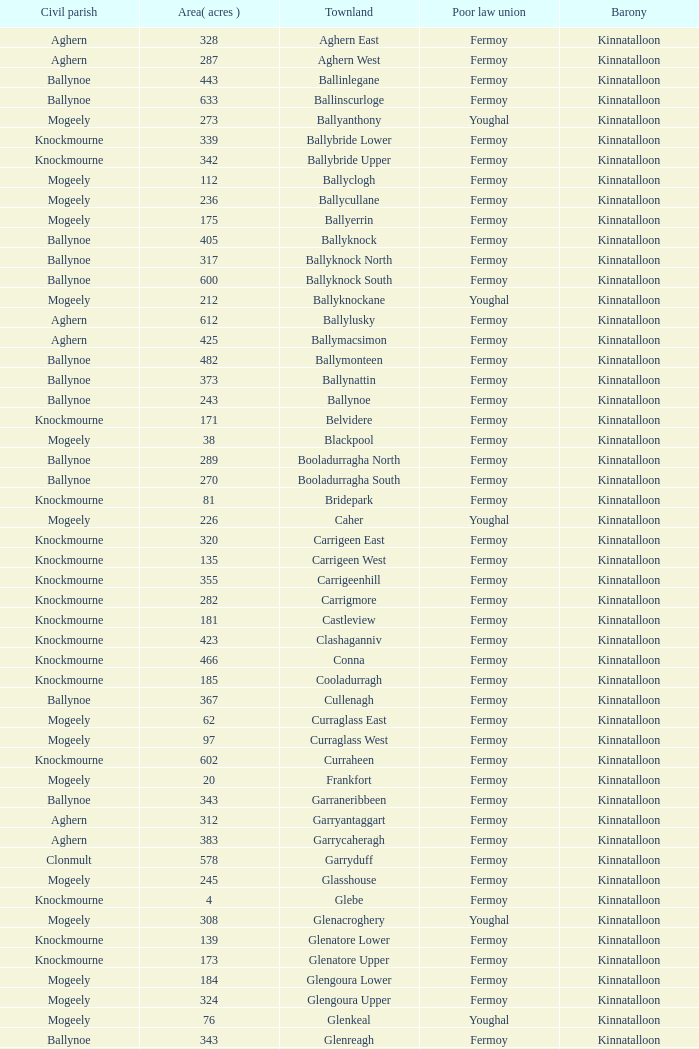Name the civil parish for garryduff Clonmult. Could you parse the entire table as a dict? {'header': ['Civil parish', 'Area( acres )', 'Townland', 'Poor law union', 'Barony'], 'rows': [['Aghern', '328', 'Aghern East', 'Fermoy', 'Kinnatalloon'], ['Aghern', '287', 'Aghern West', 'Fermoy', 'Kinnatalloon'], ['Ballynoe', '443', 'Ballinlegane', 'Fermoy', 'Kinnatalloon'], ['Ballynoe', '633', 'Ballinscurloge', 'Fermoy', 'Kinnatalloon'], ['Mogeely', '273', 'Ballyanthony', 'Youghal', 'Kinnatalloon'], ['Knockmourne', '339', 'Ballybride Lower', 'Fermoy', 'Kinnatalloon'], ['Knockmourne', '342', 'Ballybride Upper', 'Fermoy', 'Kinnatalloon'], ['Mogeely', '112', 'Ballyclogh', 'Fermoy', 'Kinnatalloon'], ['Mogeely', '236', 'Ballycullane', 'Fermoy', 'Kinnatalloon'], ['Mogeely', '175', 'Ballyerrin', 'Fermoy', 'Kinnatalloon'], ['Ballynoe', '405', 'Ballyknock', 'Fermoy', 'Kinnatalloon'], ['Ballynoe', '317', 'Ballyknock North', 'Fermoy', 'Kinnatalloon'], ['Ballynoe', '600', 'Ballyknock South', 'Fermoy', 'Kinnatalloon'], ['Mogeely', '212', 'Ballyknockane', 'Youghal', 'Kinnatalloon'], ['Aghern', '612', 'Ballylusky', 'Fermoy', 'Kinnatalloon'], ['Aghern', '425', 'Ballymacsimon', 'Fermoy', 'Kinnatalloon'], ['Ballynoe', '482', 'Ballymonteen', 'Fermoy', 'Kinnatalloon'], ['Ballynoe', '373', 'Ballynattin', 'Fermoy', 'Kinnatalloon'], ['Ballynoe', '243', 'Ballynoe', 'Fermoy', 'Kinnatalloon'], ['Knockmourne', '171', 'Belvidere', 'Fermoy', 'Kinnatalloon'], ['Mogeely', '38', 'Blackpool', 'Fermoy', 'Kinnatalloon'], ['Ballynoe', '289', 'Booladurragha North', 'Fermoy', 'Kinnatalloon'], ['Ballynoe', '270', 'Booladurragha South', 'Fermoy', 'Kinnatalloon'], ['Knockmourne', '81', 'Bridepark', 'Fermoy', 'Kinnatalloon'], ['Mogeely', '226', 'Caher', 'Youghal', 'Kinnatalloon'], ['Knockmourne', '320', 'Carrigeen East', 'Fermoy', 'Kinnatalloon'], ['Knockmourne', '135', 'Carrigeen West', 'Fermoy', 'Kinnatalloon'], ['Knockmourne', '355', 'Carrigeenhill', 'Fermoy', 'Kinnatalloon'], ['Knockmourne', '282', 'Carrigmore', 'Fermoy', 'Kinnatalloon'], ['Knockmourne', '181', 'Castleview', 'Fermoy', 'Kinnatalloon'], ['Knockmourne', '423', 'Clashaganniv', 'Fermoy', 'Kinnatalloon'], ['Knockmourne', '466', 'Conna', 'Fermoy', 'Kinnatalloon'], ['Knockmourne', '185', 'Cooladurragh', 'Fermoy', 'Kinnatalloon'], ['Ballynoe', '367', 'Cullenagh', 'Fermoy', 'Kinnatalloon'], ['Mogeely', '62', 'Curraglass East', 'Fermoy', 'Kinnatalloon'], ['Mogeely', '97', 'Curraglass West', 'Fermoy', 'Kinnatalloon'], ['Knockmourne', '602', 'Curraheen', 'Fermoy', 'Kinnatalloon'], ['Mogeely', '20', 'Frankfort', 'Fermoy', 'Kinnatalloon'], ['Ballynoe', '343', 'Garraneribbeen', 'Fermoy', 'Kinnatalloon'], ['Aghern', '312', 'Garryantaggart', 'Fermoy', 'Kinnatalloon'], ['Aghern', '383', 'Garrycaheragh', 'Fermoy', 'Kinnatalloon'], ['Clonmult', '578', 'Garryduff', 'Fermoy', 'Kinnatalloon'], ['Mogeely', '245', 'Glasshouse', 'Fermoy', 'Kinnatalloon'], ['Knockmourne', '4', 'Glebe', 'Fermoy', 'Kinnatalloon'], ['Mogeely', '308', 'Glenacroghery', 'Youghal', 'Kinnatalloon'], ['Knockmourne', '139', 'Glenatore Lower', 'Fermoy', 'Kinnatalloon'], ['Knockmourne', '173', 'Glenatore Upper', 'Fermoy', 'Kinnatalloon'], ['Mogeely', '184', 'Glengoura Lower', 'Fermoy', 'Kinnatalloon'], ['Mogeely', '324', 'Glengoura Upper', 'Fermoy', 'Kinnatalloon'], ['Mogeely', '76', 'Glenkeal', 'Youghal', 'Kinnatalloon'], ['Ballynoe', '343', 'Glenreagh', 'Fermoy', 'Kinnatalloon'], ['Ballynoe', '274', 'Glentane', 'Fermoy', 'Kinnatalloon'], ['Aghern', '284', 'Glentrasna', 'Fermoy', 'Kinnatalloon'], ['Aghern', '219', 'Glentrasna North', 'Fermoy', 'Kinnatalloon'], ['Aghern', '220', 'Glentrasna South', 'Fermoy', 'Kinnatalloon'], ['Mogeely', '78', 'Gortnafira', 'Fermoy', 'Kinnatalloon'], ['Mogeely', '8', 'Inchyallagh', 'Fermoy', 'Kinnatalloon'], ['Knockmourne', '109', 'Kilclare Lower', 'Fermoy', 'Kinnatalloon'], ['Knockmourne', '493', 'Kilclare Upper', 'Fermoy', 'Kinnatalloon'], ['Mogeely', '516', 'Kilcronat', 'Youghal', 'Kinnatalloon'], ['Mogeely', '385', 'Kilcronatmountain', 'Youghal', 'Kinnatalloon'], ['Ballynoe', '340', 'Killasseragh', 'Fermoy', 'Kinnatalloon'], ['Knockmourne', '372', 'Killavarilly', 'Fermoy', 'Kinnatalloon'], ['Mogeely', '316', 'Kilmacow', 'Fermoy', 'Kinnatalloon'], ['Mogeely', '256', 'Kilnafurrery', 'Youghal', 'Kinnatalloon'], ['Ballynoe', '535', 'Kilphillibeen', 'Fermoy', 'Kinnatalloon'], ['Mogeely', '404', 'Knockacool', 'Youghal', 'Kinnatalloon'], ['Ballynoe', '296', 'Knockakeo', 'Fermoy', 'Kinnatalloon'], ['Mogeely', '215', 'Knockanarrig', 'Youghal', 'Kinnatalloon'], ['Knockmourne', '164', 'Knockastickane', 'Fermoy', 'Kinnatalloon'], ['Aghern', '293', 'Knocknagapple', 'Fermoy', 'Kinnatalloon'], ['Mogeely', '84', 'Lackbrack', 'Fermoy', 'Kinnatalloon'], ['Mogeely', '262', 'Lacken', 'Youghal', 'Kinnatalloon'], ['Mogeely', '101', 'Lackenbehy', 'Fermoy', 'Kinnatalloon'], ['Mogeely', '41', 'Limekilnclose', 'Lismore', 'Kinnatalloon'], ['Mogeely', '114', 'Lisnabrin Lower', 'Fermoy', 'Kinnatalloon'], ['Mogeely', '217', 'Lisnabrin North', 'Fermoy', 'Kinnatalloon'], ['Mogeely', '180', 'Lisnabrin South', 'Fermoy', 'Kinnatalloon'], ['Mogeely', '28', 'Lisnabrinlodge', 'Fermoy', 'Kinnatalloon'], ['Knockmourne', '50', 'Littlegrace', 'Lismore', 'Kinnatalloon'], ['Ballynoe', '355', 'Longueville North', 'Fermoy', 'Kinnatalloon'], ['Ballynoe', '271', 'Longueville South', 'Fermoy', 'Kinnatalloon'], ['Mogeely', '160', 'Lyre', 'Youghal', 'Kinnatalloon'], ['Mogeely', '360', 'Lyre Mountain', 'Youghal', 'Kinnatalloon'], ['Mogeely', '304', 'Mogeely Lower', 'Fermoy', 'Kinnatalloon'], ['Mogeely', '247', 'Mogeely Upper', 'Fermoy', 'Kinnatalloon'], ['Knockmourne', '491', 'Monagown', 'Fermoy', 'Kinnatalloon'], ['Mogeely', '458', 'Monaloo', 'Youghal', 'Kinnatalloon'], ['Mogeely', '102', 'Mountprospect', 'Fermoy', 'Kinnatalloon'], ['Aghern', '119', 'Park', 'Fermoy', 'Kinnatalloon'], ['Mogeely', '15', 'Poundfields', 'Fermoy', 'Kinnatalloon'], ['Ballynoe', '336', 'Rathdrum', 'Fermoy', 'Kinnatalloon'], ['Britway', '339', 'Rathdrum', 'Fermoy', 'Kinnatalloon'], ['Mogeely', '318', 'Reanduff', 'Youghal', 'Kinnatalloon'], ['Mogeely', '208', 'Rearour North', 'Youghal', 'Kinnatalloon'], ['Mogeely', '223', 'Rearour South', 'Youghal', 'Kinnatalloon'], ['Mogeely', '105', 'Rosybower', 'Fermoy', 'Kinnatalloon'], ['Mogeely', '263', 'Sandyhill', 'Youghal', 'Kinnatalloon'], ['Ballynoe', '190', 'Shanaboola', 'Fermoy', 'Kinnatalloon'], ['Mogeely', '244', 'Shanakill Lower', 'Fermoy', 'Kinnatalloon'], ['Mogeely', '244', 'Shanakill Upper', 'Fermoy', 'Kinnatalloon'], ['Mogeely', '260', 'Slieveadoctor', 'Fermoy', 'Kinnatalloon'], ['Mogeely', '330', 'Templevally', 'Fermoy', 'Kinnatalloon'], ['Mogeely', '7', 'Vinepark', 'Fermoy', 'Kinnatalloon']]} 